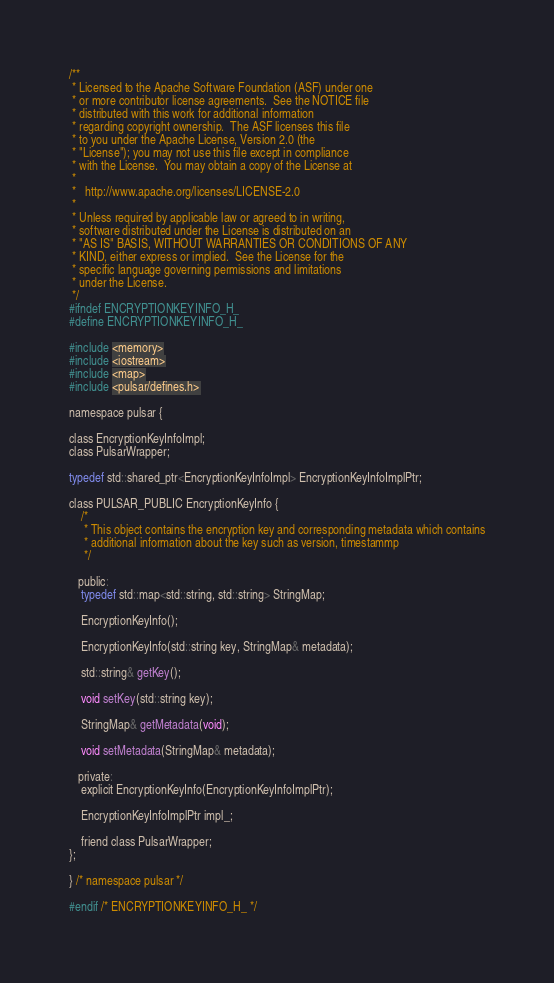Convert code to text. <code><loc_0><loc_0><loc_500><loc_500><_C_>/**
 * Licensed to the Apache Software Foundation (ASF) under one
 * or more contributor license agreements.  See the NOTICE file
 * distributed with this work for additional information
 * regarding copyright ownership.  The ASF licenses this file
 * to you under the Apache License, Version 2.0 (the
 * "License"); you may not use this file except in compliance
 * with the License.  You may obtain a copy of the License at
 *
 *   http://www.apache.org/licenses/LICENSE-2.0
 *
 * Unless required by applicable law or agreed to in writing,
 * software distributed under the License is distributed on an
 * "AS IS" BASIS, WITHOUT WARRANTIES OR CONDITIONS OF ANY
 * KIND, either express or implied.  See the License for the
 * specific language governing permissions and limitations
 * under the License.
 */
#ifndef ENCRYPTIONKEYINFO_H_
#define ENCRYPTIONKEYINFO_H_

#include <memory>
#include <iostream>
#include <map>
#include <pulsar/defines.h>

namespace pulsar {

class EncryptionKeyInfoImpl;
class PulsarWrapper;

typedef std::shared_ptr<EncryptionKeyInfoImpl> EncryptionKeyInfoImplPtr;

class PULSAR_PUBLIC EncryptionKeyInfo {
    /*
     * This object contains the encryption key and corresponding metadata which contains
     * additional information about the key such as version, timestammp
     */

   public:
    typedef std::map<std::string, std::string> StringMap;

    EncryptionKeyInfo();

    EncryptionKeyInfo(std::string key, StringMap& metadata);

    std::string& getKey();

    void setKey(std::string key);

    StringMap& getMetadata(void);

    void setMetadata(StringMap& metadata);

   private:
    explicit EncryptionKeyInfo(EncryptionKeyInfoImplPtr);

    EncryptionKeyInfoImplPtr impl_;

    friend class PulsarWrapper;
};

} /* namespace pulsar */

#endif /* ENCRYPTIONKEYINFO_H_ */
</code> 